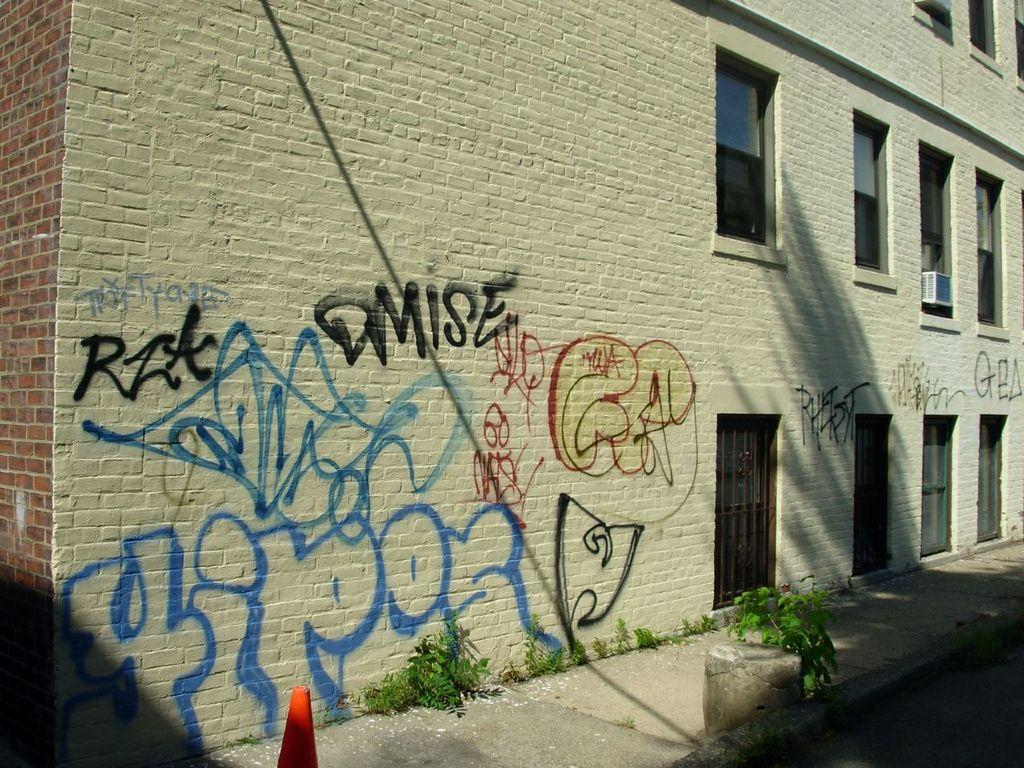What type of structure is present in the image? There is a building in the image. Can you describe any text or symbols on the building? There is writing on the wall of the building. What architectural feature can be seen on the building? There are windows visible in the image. How many people are standing in the net in the image? There is no net present in the image, so it is not possible to answer that question. 